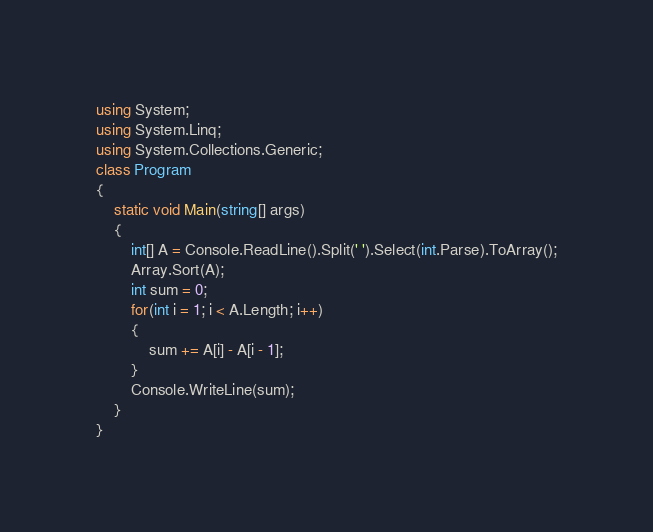Convert code to text. <code><loc_0><loc_0><loc_500><loc_500><_C#_>using System;
using System.Linq;
using System.Collections.Generic;
class Program
{
    static void Main(string[] args)
    {
        int[] A = Console.ReadLine().Split(' ').Select(int.Parse).ToArray();
        Array.Sort(A);
        int sum = 0;
        for(int i = 1; i < A.Length; i++)
        {
            sum += A[i] - A[i - 1];
        }
        Console.WriteLine(sum);
    }
}
</code> 